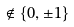Convert formula to latex. <formula><loc_0><loc_0><loc_500><loc_500>\notin \{ 0 , \pm 1 \}</formula> 